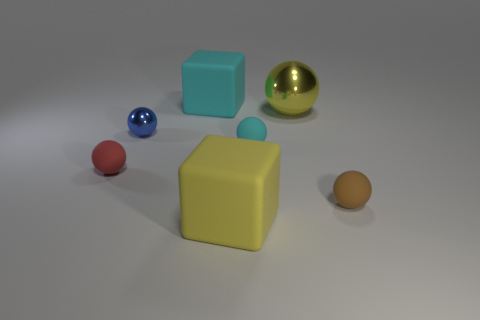Subtract all blue balls. How many balls are left? 4 Subtract all cyan rubber spheres. How many spheres are left? 4 Add 1 big cylinders. How many objects exist? 8 Subtract all gray spheres. Subtract all cyan blocks. How many spheres are left? 5 Subtract all big yellow things. Subtract all yellow shiny balls. How many objects are left? 4 Add 1 small blue objects. How many small blue objects are left? 2 Add 1 purple matte things. How many purple matte things exist? 1 Subtract 0 red blocks. How many objects are left? 7 Subtract all cubes. How many objects are left? 5 